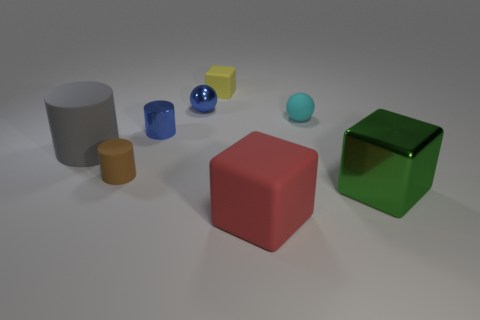There is a green thing that is the same size as the gray thing; what is it made of?
Your response must be concise. Metal. Are there any blue cylinders to the left of the tiny brown matte object?
Keep it short and to the point. No. Are there the same number of big gray cylinders in front of the tiny rubber cylinder and tiny green shiny cylinders?
Make the answer very short. Yes. There is a metal thing that is the same size as the blue metal sphere; what shape is it?
Offer a very short reply. Cylinder. What material is the red cube?
Provide a succinct answer. Rubber. There is a small object that is behind the tiny cyan thing and on the right side of the small blue ball; what color is it?
Give a very brief answer. Yellow. Is the number of red objects behind the blue cylinder the same as the number of big green shiny objects on the left side of the red block?
Ensure brevity in your answer.  Yes. What is the color of the tiny block that is made of the same material as the tiny cyan object?
Provide a short and direct response. Yellow. There is a big matte cylinder; is its color the same as the tiny ball on the left side of the big red rubber cube?
Your response must be concise. No. Is there a gray rubber cylinder that is on the right side of the tiny matte object that is behind the small blue shiny object behind the small blue shiny cylinder?
Give a very brief answer. No. 